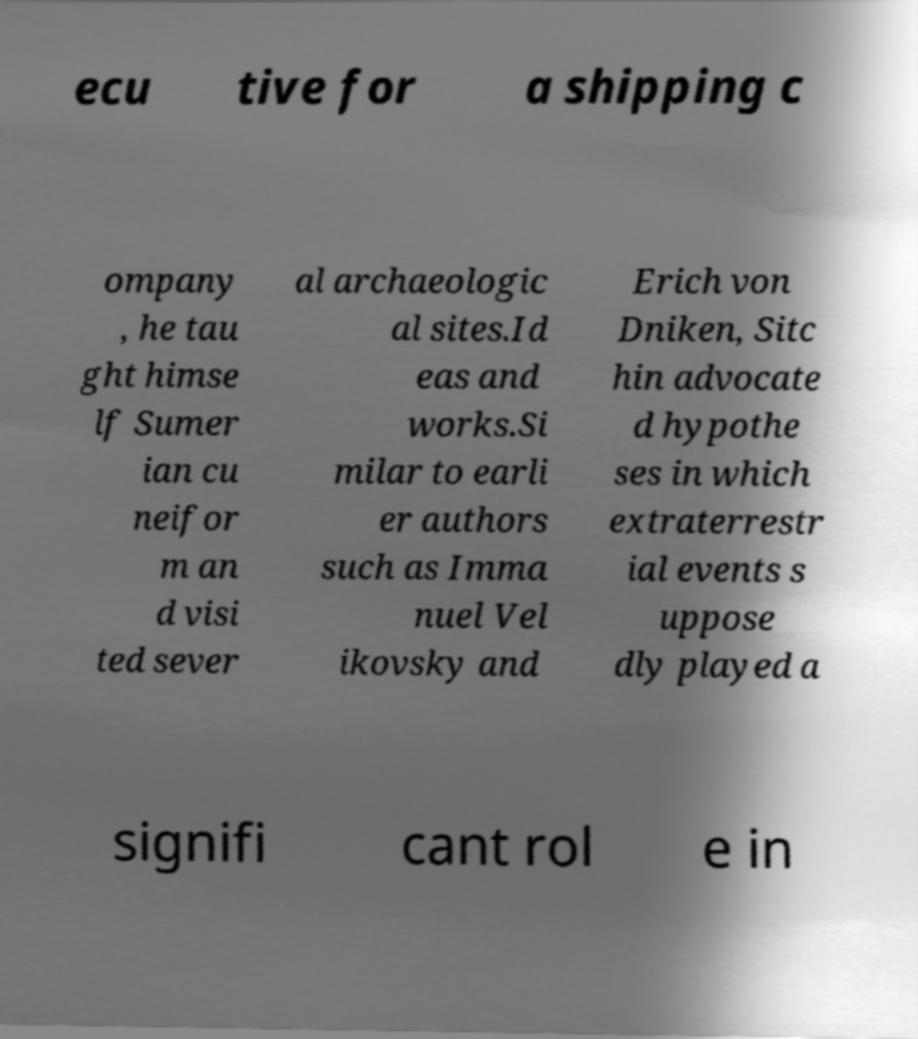What messages or text are displayed in this image? I need them in a readable, typed format. ecu tive for a shipping c ompany , he tau ght himse lf Sumer ian cu neifor m an d visi ted sever al archaeologic al sites.Id eas and works.Si milar to earli er authors such as Imma nuel Vel ikovsky and Erich von Dniken, Sitc hin advocate d hypothe ses in which extraterrestr ial events s uppose dly played a signifi cant rol e in 